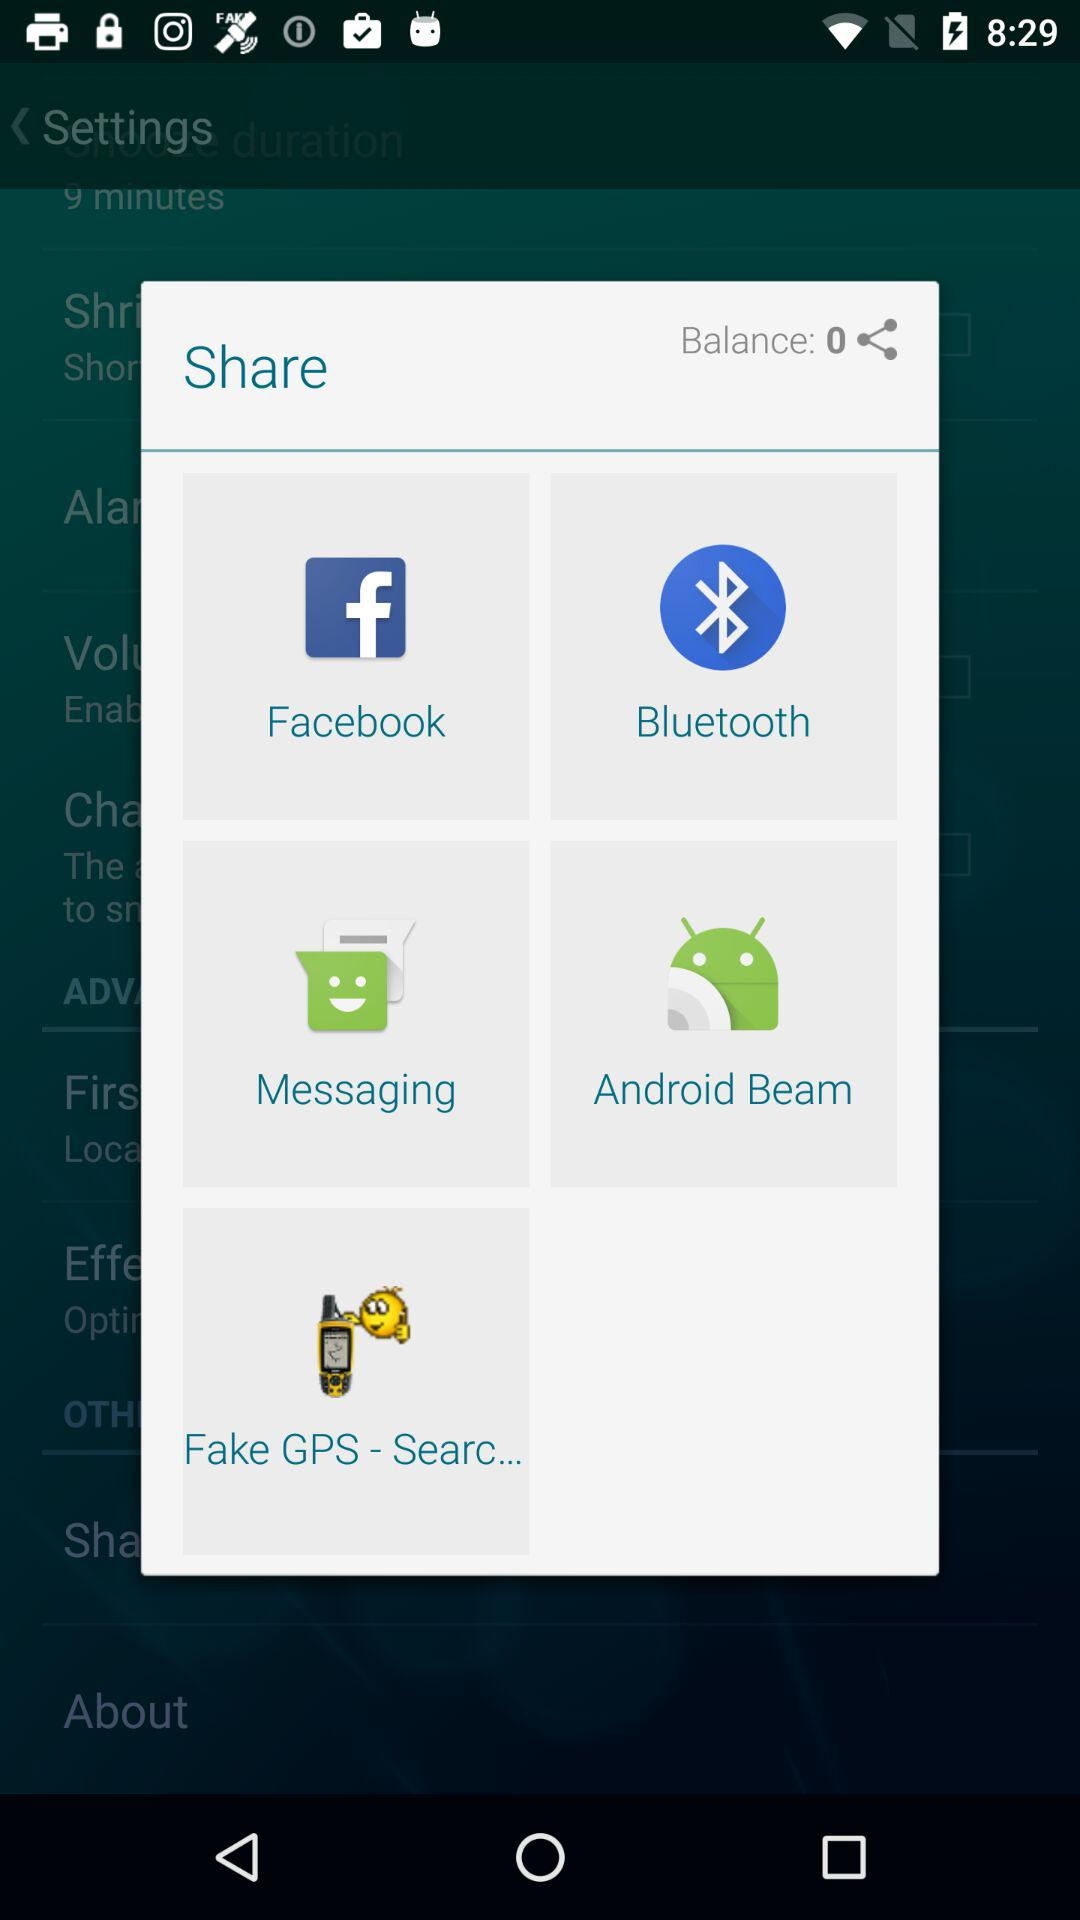How much money is in my account?
Answer the question using a single word or phrase. 0 